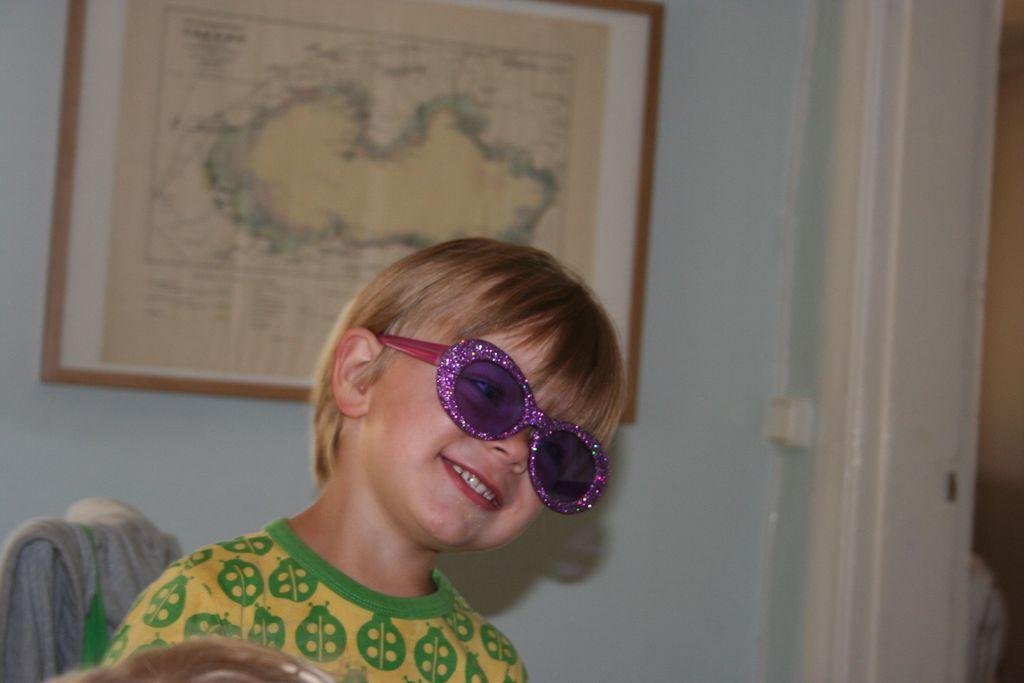What is the main subject of the image? There is a child in the image. What is the child doing in the image? The child is sitting on a chair and smiling. What accessory is the child wearing? The child is wearing glasses. What can be seen in the background of the image? There is a wall in the background of the image, with a photo frame and a map on it. How does the child tie a knot with their feet in the image? There is no indication in the image that the child is tying a knot or using their feet for any purpose. 